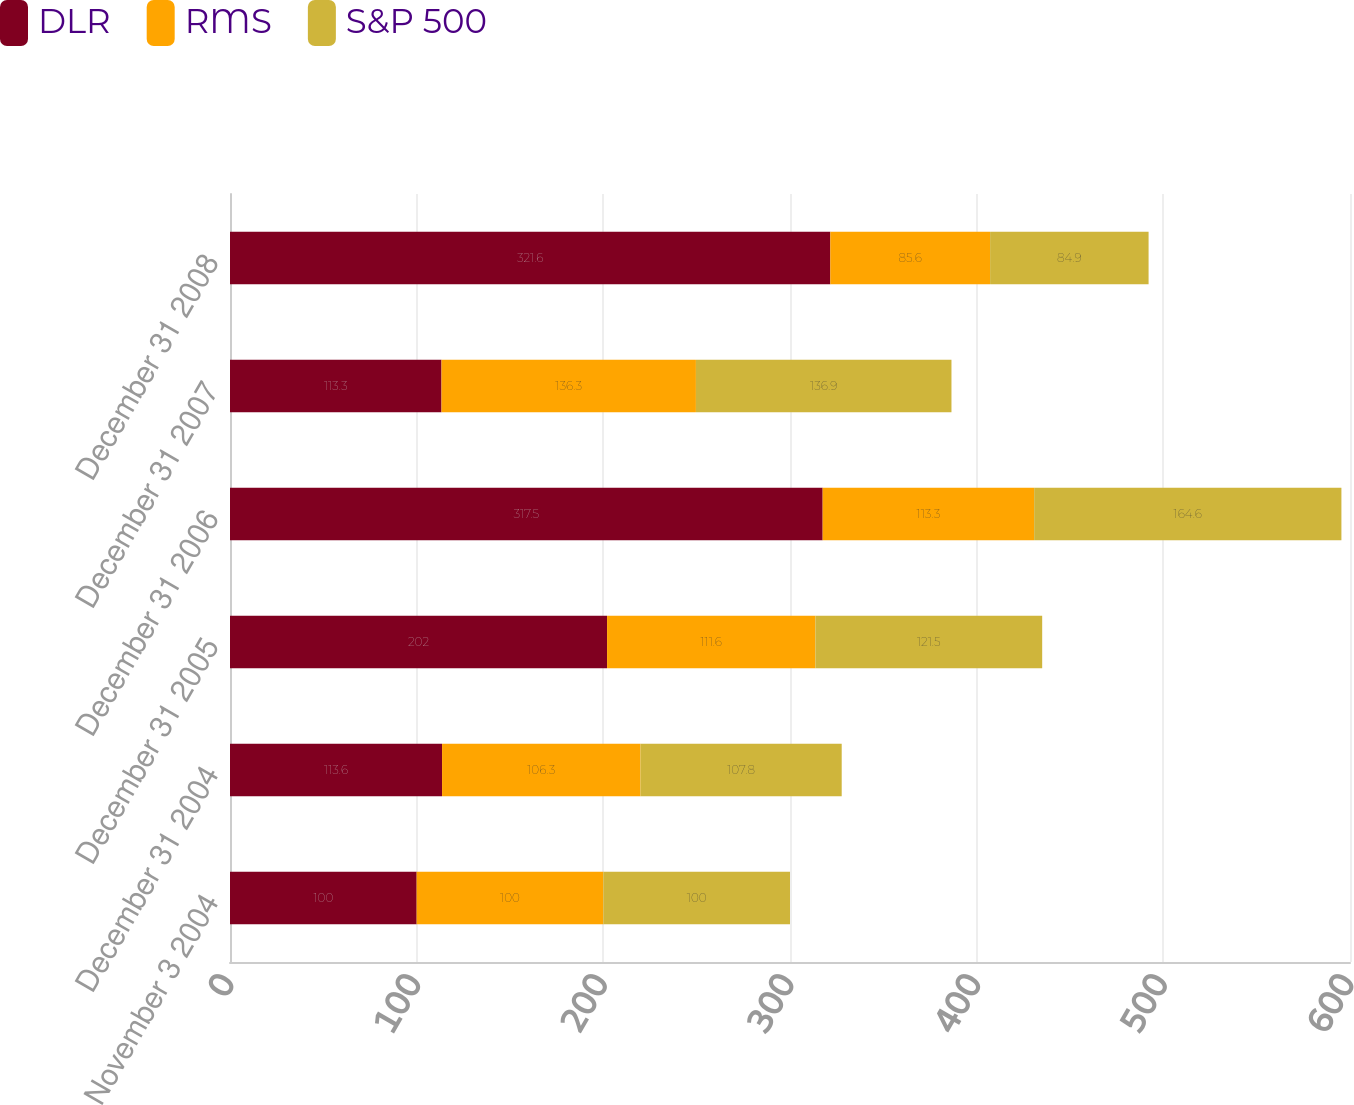Convert chart. <chart><loc_0><loc_0><loc_500><loc_500><stacked_bar_chart><ecel><fcel>November 3 2004<fcel>December 31 2004<fcel>December 31 2005<fcel>December 31 2006<fcel>December 31 2007<fcel>December 31 2008<nl><fcel>DLR<fcel>100<fcel>113.6<fcel>202<fcel>317.5<fcel>113.3<fcel>321.6<nl><fcel>RMS<fcel>100<fcel>106.3<fcel>111.6<fcel>113.3<fcel>136.3<fcel>85.6<nl><fcel>S&P 500<fcel>100<fcel>107.8<fcel>121.5<fcel>164.6<fcel>136.9<fcel>84.9<nl></chart> 